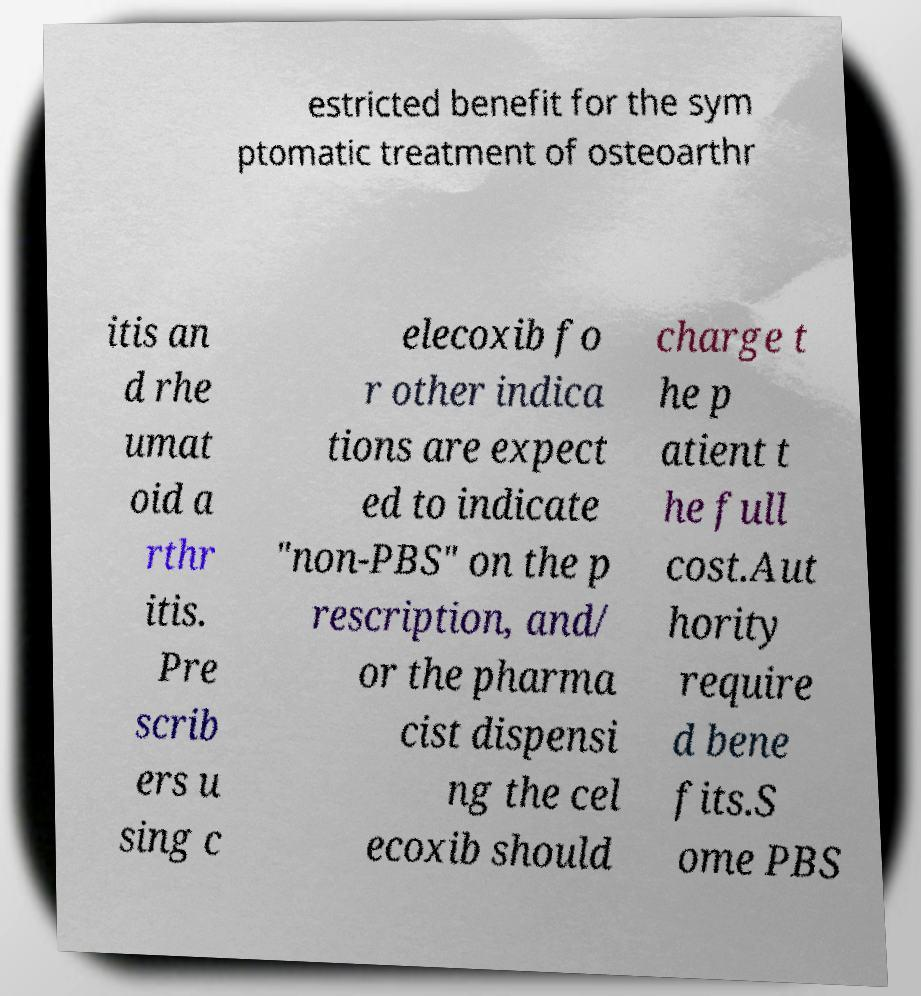Can you accurately transcribe the text from the provided image for me? estricted benefit for the sym ptomatic treatment of osteoarthr itis an d rhe umat oid a rthr itis. Pre scrib ers u sing c elecoxib fo r other indica tions are expect ed to indicate "non-PBS" on the p rescription, and/ or the pharma cist dispensi ng the cel ecoxib should charge t he p atient t he full cost.Aut hority require d bene fits.S ome PBS 